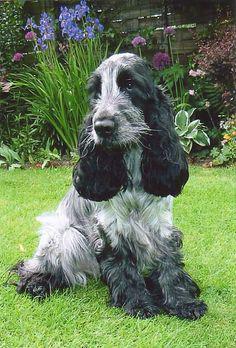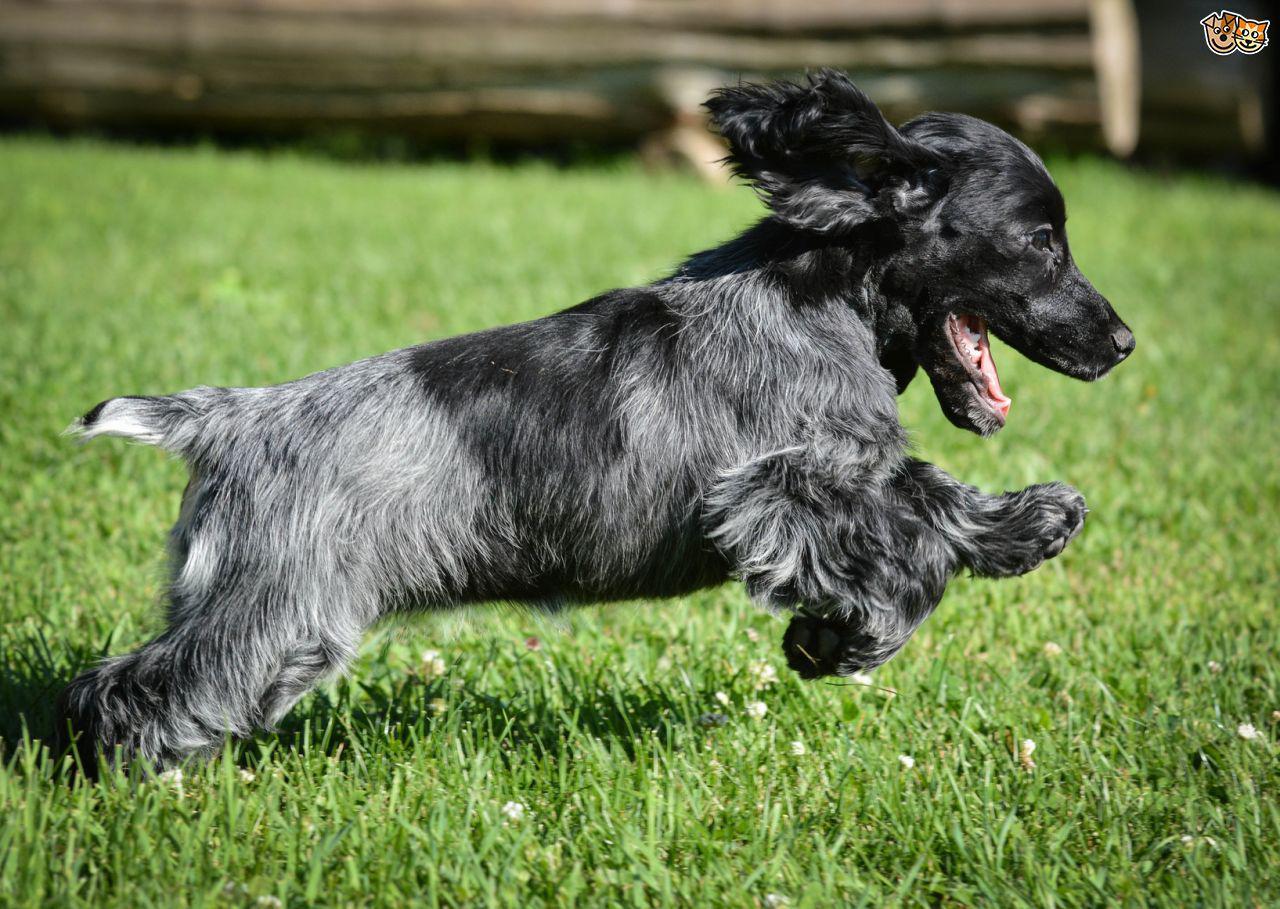The first image is the image on the left, the second image is the image on the right. Considering the images on both sides, is "One of the dogs is carrying something in its mouth." valid? Answer yes or no. No. The first image is the image on the left, the second image is the image on the right. Considering the images on both sides, is "The dog in the image on the right is carrying something in it's mouth." valid? Answer yes or no. No. 